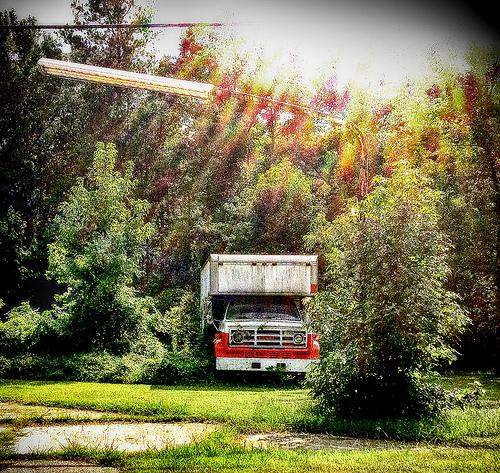Question: what kind of scene is this?
Choices:
A. Indoor.
B. Beach.
C. Outdoor.
D. Holiday.
Answer with the letter. Answer: C 